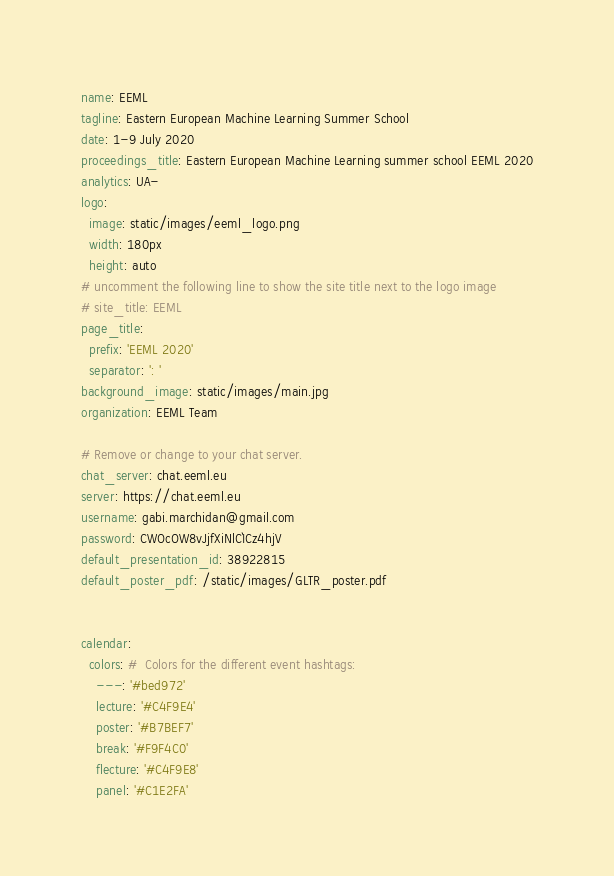<code> <loc_0><loc_0><loc_500><loc_500><_YAML_>name: EEML
tagline: Eastern European Machine Learning Summer School
date: 1-9 July 2020
proceedings_title: Eastern European Machine Learning summer school EEML 2020
analytics: UA-
logo:
  image: static/images/eeml_logo.png
  width: 180px
  height: auto
# uncomment the following line to show the site title next to the logo image
# site_title: EEML
page_title:
  prefix: 'EEML 2020'
  separator: ': '
background_image: static/images/main.jpg
organization: EEML Team

# Remove or change to your chat server.
chat_server: chat.eeml.eu
server: https://chat.eeml.eu
username: gabi.marchidan@gmail.com
password: CWOcOW8vJjfXiNlC`ICz4hjV
default_presentation_id: 38922815
default_poster_pdf: /static/images/GLTR_poster.pdf


calendar:
  colors: #  Colors for the different event hashtags:
    ---: '#bed972'
    lecture: '#C4F9E4'
    poster: '#B7BEF7'
    break: '#F9F4C0'
    flecture: '#C4F9E8'
    panel: '#C1E2FA'</code> 